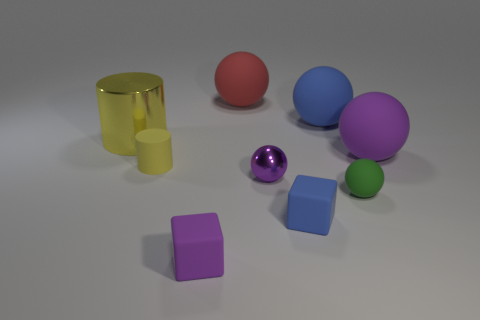There is a red thing that is the same shape as the big blue object; what is its material?
Provide a succinct answer. Rubber. The small thing that is the same color as the big cylinder is what shape?
Your answer should be compact. Cylinder. How many metallic things have the same shape as the red rubber thing?
Provide a short and direct response. 1. Is the shape of the large yellow thing the same as the tiny blue rubber object?
Your response must be concise. No. The metallic cylinder has what size?
Your answer should be very brief. Large. What number of green rubber objects are the same size as the yellow metallic cylinder?
Your answer should be compact. 0. Is the size of the rubber cube on the right side of the red matte thing the same as the cylinder in front of the large yellow metal cylinder?
Give a very brief answer. Yes. What shape is the object in front of the tiny blue rubber cube?
Keep it short and to the point. Cube. What material is the large ball that is behind the blue object behind the yellow matte thing made of?
Provide a short and direct response. Rubber. Are there any tiny objects of the same color as the large metal thing?
Offer a very short reply. Yes. 